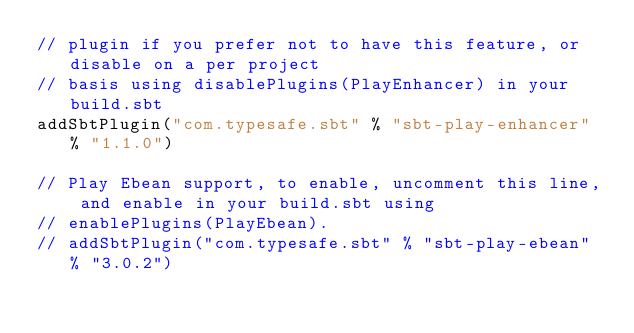Convert code to text. <code><loc_0><loc_0><loc_500><loc_500><_Scala_>// plugin if you prefer not to have this feature, or disable on a per project
// basis using disablePlugins(PlayEnhancer) in your build.sbt
addSbtPlugin("com.typesafe.sbt" % "sbt-play-enhancer" % "1.1.0")

// Play Ebean support, to enable, uncomment this line, and enable in your build.sbt using
// enablePlugins(PlayEbean).
// addSbtPlugin("com.typesafe.sbt" % "sbt-play-ebean" % "3.0.2")
</code> 